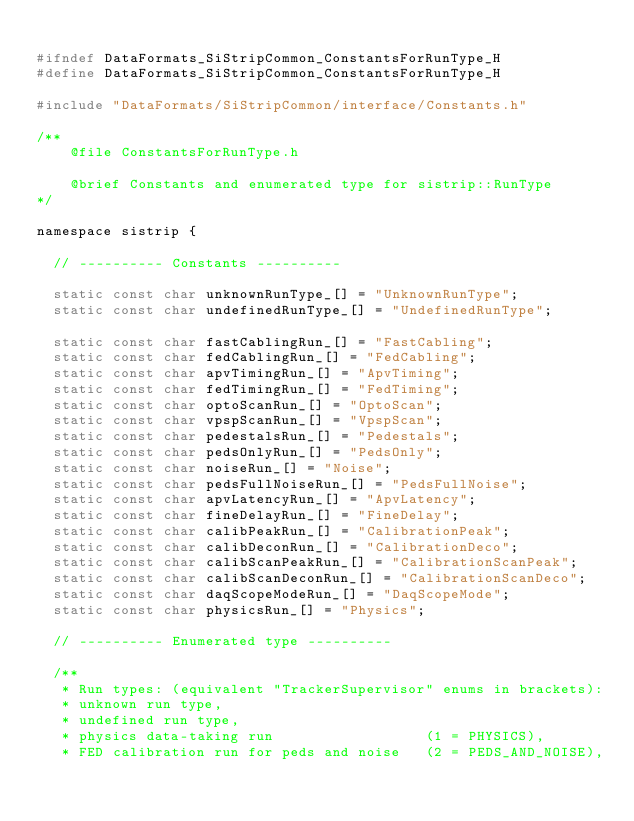Convert code to text. <code><loc_0><loc_0><loc_500><loc_500><_C_>
#ifndef DataFormats_SiStripCommon_ConstantsForRunType_H
#define DataFormats_SiStripCommon_ConstantsForRunType_H

#include "DataFormats/SiStripCommon/interface/Constants.h"

/** 
    @file ConstantsForRunType.h

    @brief Constants and enumerated type for sistrip::RunType
*/

namespace sistrip {

  // ---------- Constants ----------

  static const char unknownRunType_[] = "UnknownRunType";
  static const char undefinedRunType_[] = "UndefinedRunType";

  static const char fastCablingRun_[] = "FastCabling";
  static const char fedCablingRun_[] = "FedCabling";
  static const char apvTimingRun_[] = "ApvTiming";
  static const char fedTimingRun_[] = "FedTiming";
  static const char optoScanRun_[] = "OptoScan";
  static const char vpspScanRun_[] = "VpspScan";
  static const char pedestalsRun_[] = "Pedestals";
  static const char pedsOnlyRun_[] = "PedsOnly";
  static const char noiseRun_[] = "Noise";
  static const char pedsFullNoiseRun_[] = "PedsFullNoise";
  static const char apvLatencyRun_[] = "ApvLatency";
  static const char fineDelayRun_[] = "FineDelay";
  static const char calibPeakRun_[] = "CalibrationPeak";
  static const char calibDeconRun_[] = "CalibrationDeco";
  static const char calibScanPeakRun_[] = "CalibrationScanPeak";
  static const char calibScanDeconRun_[] = "CalibrationScanDeco";
  static const char daqScopeModeRun_[] = "DaqScopeMode";
  static const char physicsRun_[] = "Physics";

  // ---------- Enumerated type ----------

  /** 
   * Run types: (equivalent "TrackerSupervisor" enums in brackets): 
   * unknown run type,
   * undefined run type,
   * physics data-taking run                  (1 = PHYSICS), 
   * FED calibration run for peds and noise   (2 = PEDS_AND_NOISE), </code> 